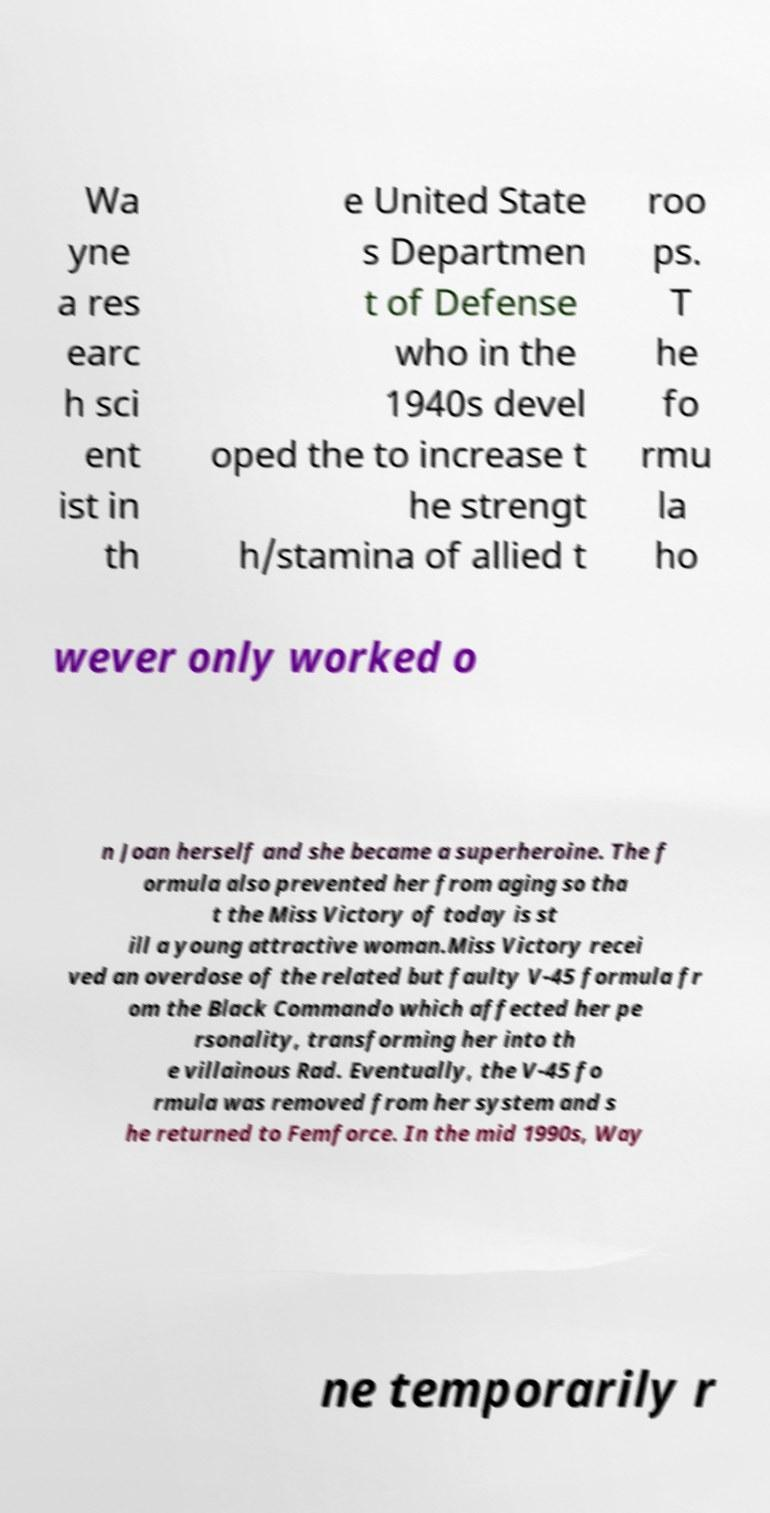Can you read and provide the text displayed in the image?This photo seems to have some interesting text. Can you extract and type it out for me? Wa yne a res earc h sci ent ist in th e United State s Departmen t of Defense who in the 1940s devel oped the to increase t he strengt h/stamina of allied t roo ps. T he fo rmu la ho wever only worked o n Joan herself and she became a superheroine. The f ormula also prevented her from aging so tha t the Miss Victory of today is st ill a young attractive woman.Miss Victory recei ved an overdose of the related but faulty V-45 formula fr om the Black Commando which affected her pe rsonality, transforming her into th e villainous Rad. Eventually, the V-45 fo rmula was removed from her system and s he returned to Femforce. In the mid 1990s, Way ne temporarily r 